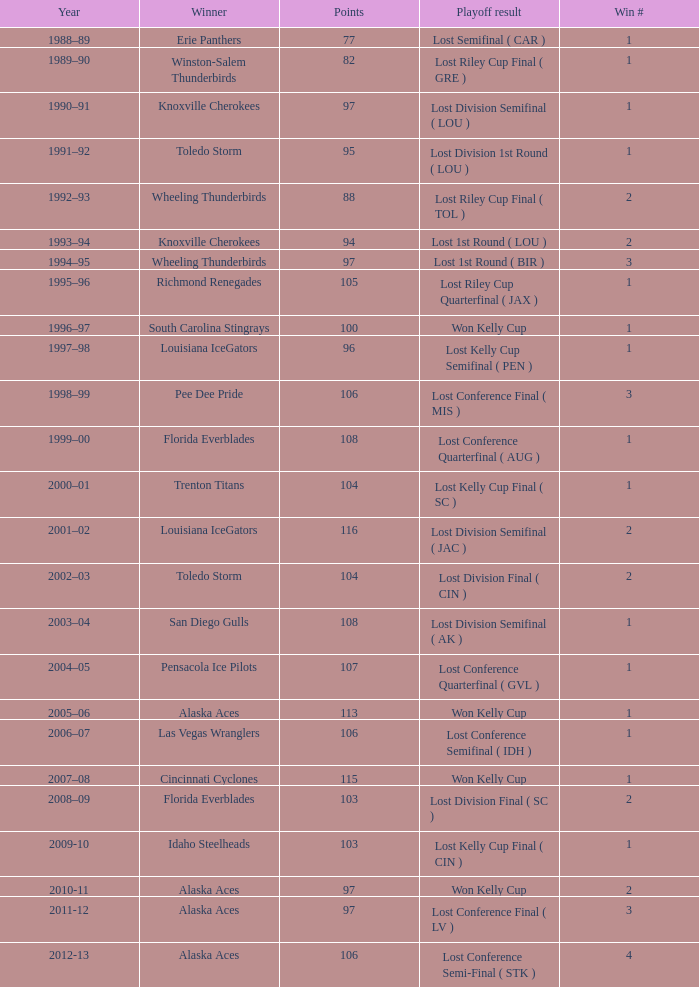What is Winner, when Win # is greater than 1, and when Points is less than 94? Wheeling Thunderbirds. 